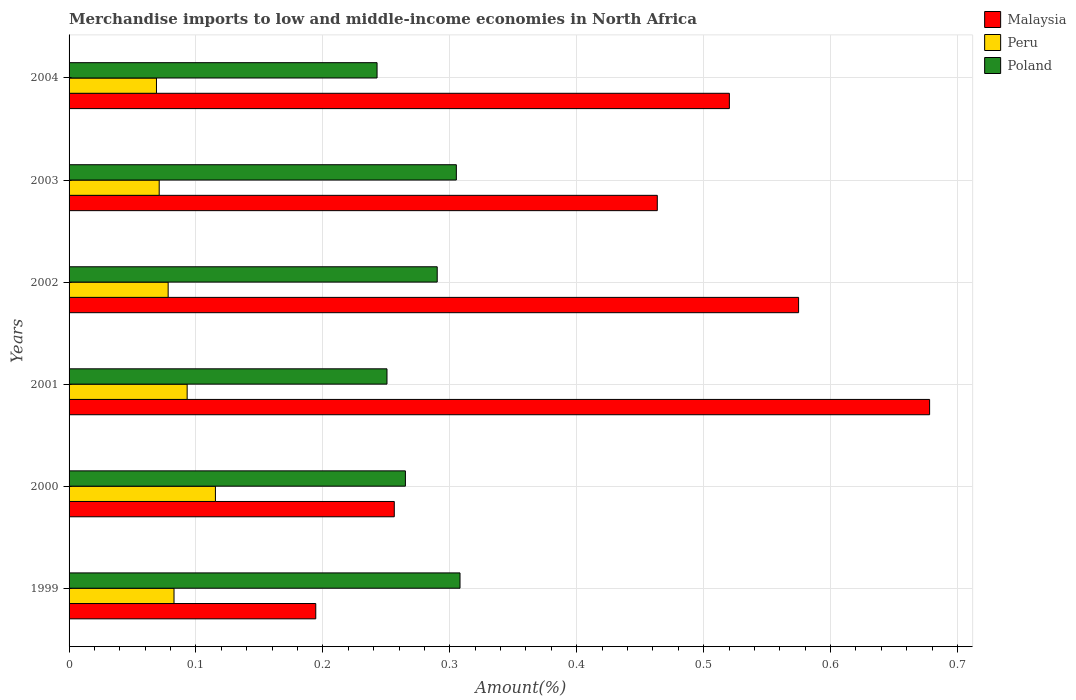How many different coloured bars are there?
Give a very brief answer. 3. In how many cases, is the number of bars for a given year not equal to the number of legend labels?
Keep it short and to the point. 0. What is the percentage of amount earned from merchandise imports in Peru in 2003?
Your response must be concise. 0.07. Across all years, what is the maximum percentage of amount earned from merchandise imports in Peru?
Offer a very short reply. 0.12. Across all years, what is the minimum percentage of amount earned from merchandise imports in Malaysia?
Your answer should be very brief. 0.19. In which year was the percentage of amount earned from merchandise imports in Peru maximum?
Your answer should be very brief. 2000. What is the total percentage of amount earned from merchandise imports in Peru in the graph?
Provide a succinct answer. 0.51. What is the difference between the percentage of amount earned from merchandise imports in Poland in 1999 and that in 2003?
Provide a succinct answer. 0. What is the difference between the percentage of amount earned from merchandise imports in Peru in 2004 and the percentage of amount earned from merchandise imports in Malaysia in 2001?
Give a very brief answer. -0.61. What is the average percentage of amount earned from merchandise imports in Malaysia per year?
Ensure brevity in your answer.  0.45. In the year 2004, what is the difference between the percentage of amount earned from merchandise imports in Poland and percentage of amount earned from merchandise imports in Peru?
Offer a very short reply. 0.17. In how many years, is the percentage of amount earned from merchandise imports in Peru greater than 0.28 %?
Give a very brief answer. 0. What is the ratio of the percentage of amount earned from merchandise imports in Poland in 2002 to that in 2004?
Provide a succinct answer. 1.2. Is the percentage of amount earned from merchandise imports in Peru in 1999 less than that in 2001?
Your answer should be very brief. Yes. Is the difference between the percentage of amount earned from merchandise imports in Poland in 1999 and 2004 greater than the difference between the percentage of amount earned from merchandise imports in Peru in 1999 and 2004?
Offer a very short reply. Yes. What is the difference between the highest and the second highest percentage of amount earned from merchandise imports in Peru?
Your answer should be very brief. 0.02. What is the difference between the highest and the lowest percentage of amount earned from merchandise imports in Poland?
Your answer should be compact. 0.07. Is the sum of the percentage of amount earned from merchandise imports in Peru in 1999 and 2001 greater than the maximum percentage of amount earned from merchandise imports in Poland across all years?
Offer a very short reply. No. What does the 1st bar from the bottom in 1999 represents?
Provide a succinct answer. Malaysia. How many bars are there?
Make the answer very short. 18. How many years are there in the graph?
Your answer should be very brief. 6. Are the values on the major ticks of X-axis written in scientific E-notation?
Provide a succinct answer. No. Does the graph contain any zero values?
Provide a succinct answer. No. How are the legend labels stacked?
Give a very brief answer. Vertical. What is the title of the graph?
Offer a very short reply. Merchandise imports to low and middle-income economies in North Africa. Does "Chad" appear as one of the legend labels in the graph?
Offer a very short reply. No. What is the label or title of the X-axis?
Offer a very short reply. Amount(%). What is the Amount(%) of Malaysia in 1999?
Give a very brief answer. 0.19. What is the Amount(%) in Peru in 1999?
Make the answer very short. 0.08. What is the Amount(%) of Poland in 1999?
Provide a short and direct response. 0.31. What is the Amount(%) of Malaysia in 2000?
Provide a succinct answer. 0.26. What is the Amount(%) of Peru in 2000?
Make the answer very short. 0.12. What is the Amount(%) of Poland in 2000?
Ensure brevity in your answer.  0.27. What is the Amount(%) of Malaysia in 2001?
Your answer should be compact. 0.68. What is the Amount(%) in Peru in 2001?
Offer a terse response. 0.09. What is the Amount(%) of Poland in 2001?
Provide a short and direct response. 0.25. What is the Amount(%) in Malaysia in 2002?
Make the answer very short. 0.57. What is the Amount(%) of Peru in 2002?
Your response must be concise. 0.08. What is the Amount(%) in Poland in 2002?
Your answer should be compact. 0.29. What is the Amount(%) of Malaysia in 2003?
Make the answer very short. 0.46. What is the Amount(%) in Peru in 2003?
Offer a terse response. 0.07. What is the Amount(%) in Poland in 2003?
Offer a very short reply. 0.31. What is the Amount(%) in Malaysia in 2004?
Give a very brief answer. 0.52. What is the Amount(%) in Peru in 2004?
Your answer should be compact. 0.07. What is the Amount(%) of Poland in 2004?
Give a very brief answer. 0.24. Across all years, what is the maximum Amount(%) of Malaysia?
Keep it short and to the point. 0.68. Across all years, what is the maximum Amount(%) of Peru?
Your answer should be compact. 0.12. Across all years, what is the maximum Amount(%) of Poland?
Your answer should be compact. 0.31. Across all years, what is the minimum Amount(%) in Malaysia?
Provide a succinct answer. 0.19. Across all years, what is the minimum Amount(%) in Peru?
Make the answer very short. 0.07. Across all years, what is the minimum Amount(%) of Poland?
Provide a succinct answer. 0.24. What is the total Amount(%) of Malaysia in the graph?
Give a very brief answer. 2.69. What is the total Amount(%) of Peru in the graph?
Provide a succinct answer. 0.51. What is the total Amount(%) in Poland in the graph?
Your answer should be very brief. 1.66. What is the difference between the Amount(%) in Malaysia in 1999 and that in 2000?
Keep it short and to the point. -0.06. What is the difference between the Amount(%) in Peru in 1999 and that in 2000?
Offer a terse response. -0.03. What is the difference between the Amount(%) in Poland in 1999 and that in 2000?
Keep it short and to the point. 0.04. What is the difference between the Amount(%) of Malaysia in 1999 and that in 2001?
Make the answer very short. -0.48. What is the difference between the Amount(%) in Peru in 1999 and that in 2001?
Provide a succinct answer. -0.01. What is the difference between the Amount(%) in Poland in 1999 and that in 2001?
Offer a terse response. 0.06. What is the difference between the Amount(%) of Malaysia in 1999 and that in 2002?
Ensure brevity in your answer.  -0.38. What is the difference between the Amount(%) in Peru in 1999 and that in 2002?
Your response must be concise. 0. What is the difference between the Amount(%) in Poland in 1999 and that in 2002?
Make the answer very short. 0.02. What is the difference between the Amount(%) of Malaysia in 1999 and that in 2003?
Give a very brief answer. -0.27. What is the difference between the Amount(%) of Peru in 1999 and that in 2003?
Ensure brevity in your answer.  0.01. What is the difference between the Amount(%) in Poland in 1999 and that in 2003?
Keep it short and to the point. 0. What is the difference between the Amount(%) of Malaysia in 1999 and that in 2004?
Give a very brief answer. -0.33. What is the difference between the Amount(%) in Peru in 1999 and that in 2004?
Offer a terse response. 0.01. What is the difference between the Amount(%) of Poland in 1999 and that in 2004?
Give a very brief answer. 0.07. What is the difference between the Amount(%) in Malaysia in 2000 and that in 2001?
Offer a terse response. -0.42. What is the difference between the Amount(%) in Peru in 2000 and that in 2001?
Provide a succinct answer. 0.02. What is the difference between the Amount(%) in Poland in 2000 and that in 2001?
Keep it short and to the point. 0.01. What is the difference between the Amount(%) of Malaysia in 2000 and that in 2002?
Keep it short and to the point. -0.32. What is the difference between the Amount(%) in Peru in 2000 and that in 2002?
Your response must be concise. 0.04. What is the difference between the Amount(%) in Poland in 2000 and that in 2002?
Offer a terse response. -0.03. What is the difference between the Amount(%) of Malaysia in 2000 and that in 2003?
Your answer should be very brief. -0.21. What is the difference between the Amount(%) of Peru in 2000 and that in 2003?
Offer a terse response. 0.04. What is the difference between the Amount(%) of Poland in 2000 and that in 2003?
Your answer should be compact. -0.04. What is the difference between the Amount(%) in Malaysia in 2000 and that in 2004?
Give a very brief answer. -0.26. What is the difference between the Amount(%) of Peru in 2000 and that in 2004?
Your answer should be very brief. 0.05. What is the difference between the Amount(%) in Poland in 2000 and that in 2004?
Provide a short and direct response. 0.02. What is the difference between the Amount(%) in Malaysia in 2001 and that in 2002?
Your answer should be very brief. 0.1. What is the difference between the Amount(%) of Peru in 2001 and that in 2002?
Provide a short and direct response. 0.01. What is the difference between the Amount(%) of Poland in 2001 and that in 2002?
Make the answer very short. -0.04. What is the difference between the Amount(%) of Malaysia in 2001 and that in 2003?
Keep it short and to the point. 0.21. What is the difference between the Amount(%) in Peru in 2001 and that in 2003?
Your answer should be compact. 0.02. What is the difference between the Amount(%) in Poland in 2001 and that in 2003?
Your response must be concise. -0.05. What is the difference between the Amount(%) of Malaysia in 2001 and that in 2004?
Offer a terse response. 0.16. What is the difference between the Amount(%) of Peru in 2001 and that in 2004?
Make the answer very short. 0.02. What is the difference between the Amount(%) of Poland in 2001 and that in 2004?
Make the answer very short. 0.01. What is the difference between the Amount(%) in Malaysia in 2002 and that in 2003?
Provide a short and direct response. 0.11. What is the difference between the Amount(%) of Peru in 2002 and that in 2003?
Your response must be concise. 0.01. What is the difference between the Amount(%) in Poland in 2002 and that in 2003?
Your answer should be very brief. -0.02. What is the difference between the Amount(%) of Malaysia in 2002 and that in 2004?
Your response must be concise. 0.05. What is the difference between the Amount(%) of Peru in 2002 and that in 2004?
Ensure brevity in your answer.  0.01. What is the difference between the Amount(%) of Poland in 2002 and that in 2004?
Your answer should be very brief. 0.05. What is the difference between the Amount(%) in Malaysia in 2003 and that in 2004?
Provide a succinct answer. -0.06. What is the difference between the Amount(%) of Peru in 2003 and that in 2004?
Your answer should be compact. 0. What is the difference between the Amount(%) in Poland in 2003 and that in 2004?
Provide a succinct answer. 0.06. What is the difference between the Amount(%) of Malaysia in 1999 and the Amount(%) of Peru in 2000?
Make the answer very short. 0.08. What is the difference between the Amount(%) of Malaysia in 1999 and the Amount(%) of Poland in 2000?
Make the answer very short. -0.07. What is the difference between the Amount(%) in Peru in 1999 and the Amount(%) in Poland in 2000?
Offer a very short reply. -0.18. What is the difference between the Amount(%) of Malaysia in 1999 and the Amount(%) of Peru in 2001?
Keep it short and to the point. 0.1. What is the difference between the Amount(%) in Malaysia in 1999 and the Amount(%) in Poland in 2001?
Give a very brief answer. -0.06. What is the difference between the Amount(%) in Peru in 1999 and the Amount(%) in Poland in 2001?
Provide a succinct answer. -0.17. What is the difference between the Amount(%) of Malaysia in 1999 and the Amount(%) of Peru in 2002?
Keep it short and to the point. 0.12. What is the difference between the Amount(%) in Malaysia in 1999 and the Amount(%) in Poland in 2002?
Provide a short and direct response. -0.1. What is the difference between the Amount(%) of Peru in 1999 and the Amount(%) of Poland in 2002?
Offer a terse response. -0.21. What is the difference between the Amount(%) in Malaysia in 1999 and the Amount(%) in Peru in 2003?
Offer a very short reply. 0.12. What is the difference between the Amount(%) in Malaysia in 1999 and the Amount(%) in Poland in 2003?
Your answer should be very brief. -0.11. What is the difference between the Amount(%) of Peru in 1999 and the Amount(%) of Poland in 2003?
Your answer should be compact. -0.22. What is the difference between the Amount(%) in Malaysia in 1999 and the Amount(%) in Peru in 2004?
Offer a very short reply. 0.13. What is the difference between the Amount(%) of Malaysia in 1999 and the Amount(%) of Poland in 2004?
Your answer should be compact. -0.05. What is the difference between the Amount(%) of Peru in 1999 and the Amount(%) of Poland in 2004?
Give a very brief answer. -0.16. What is the difference between the Amount(%) in Malaysia in 2000 and the Amount(%) in Peru in 2001?
Offer a very short reply. 0.16. What is the difference between the Amount(%) of Malaysia in 2000 and the Amount(%) of Poland in 2001?
Make the answer very short. 0.01. What is the difference between the Amount(%) in Peru in 2000 and the Amount(%) in Poland in 2001?
Offer a terse response. -0.14. What is the difference between the Amount(%) of Malaysia in 2000 and the Amount(%) of Peru in 2002?
Ensure brevity in your answer.  0.18. What is the difference between the Amount(%) in Malaysia in 2000 and the Amount(%) in Poland in 2002?
Make the answer very short. -0.03. What is the difference between the Amount(%) of Peru in 2000 and the Amount(%) of Poland in 2002?
Offer a very short reply. -0.17. What is the difference between the Amount(%) of Malaysia in 2000 and the Amount(%) of Peru in 2003?
Offer a terse response. 0.19. What is the difference between the Amount(%) of Malaysia in 2000 and the Amount(%) of Poland in 2003?
Ensure brevity in your answer.  -0.05. What is the difference between the Amount(%) of Peru in 2000 and the Amount(%) of Poland in 2003?
Your answer should be compact. -0.19. What is the difference between the Amount(%) in Malaysia in 2000 and the Amount(%) in Peru in 2004?
Offer a very short reply. 0.19. What is the difference between the Amount(%) of Malaysia in 2000 and the Amount(%) of Poland in 2004?
Your response must be concise. 0.01. What is the difference between the Amount(%) in Peru in 2000 and the Amount(%) in Poland in 2004?
Make the answer very short. -0.13. What is the difference between the Amount(%) in Malaysia in 2001 and the Amount(%) in Peru in 2002?
Your answer should be very brief. 0.6. What is the difference between the Amount(%) of Malaysia in 2001 and the Amount(%) of Poland in 2002?
Make the answer very short. 0.39. What is the difference between the Amount(%) in Peru in 2001 and the Amount(%) in Poland in 2002?
Make the answer very short. -0.2. What is the difference between the Amount(%) of Malaysia in 2001 and the Amount(%) of Peru in 2003?
Your answer should be very brief. 0.61. What is the difference between the Amount(%) of Malaysia in 2001 and the Amount(%) of Poland in 2003?
Ensure brevity in your answer.  0.37. What is the difference between the Amount(%) in Peru in 2001 and the Amount(%) in Poland in 2003?
Your answer should be very brief. -0.21. What is the difference between the Amount(%) of Malaysia in 2001 and the Amount(%) of Peru in 2004?
Provide a succinct answer. 0.61. What is the difference between the Amount(%) in Malaysia in 2001 and the Amount(%) in Poland in 2004?
Ensure brevity in your answer.  0.44. What is the difference between the Amount(%) of Peru in 2001 and the Amount(%) of Poland in 2004?
Offer a terse response. -0.15. What is the difference between the Amount(%) of Malaysia in 2002 and the Amount(%) of Peru in 2003?
Your answer should be compact. 0.5. What is the difference between the Amount(%) in Malaysia in 2002 and the Amount(%) in Poland in 2003?
Keep it short and to the point. 0.27. What is the difference between the Amount(%) of Peru in 2002 and the Amount(%) of Poland in 2003?
Offer a very short reply. -0.23. What is the difference between the Amount(%) in Malaysia in 2002 and the Amount(%) in Peru in 2004?
Make the answer very short. 0.51. What is the difference between the Amount(%) in Malaysia in 2002 and the Amount(%) in Poland in 2004?
Keep it short and to the point. 0.33. What is the difference between the Amount(%) of Peru in 2002 and the Amount(%) of Poland in 2004?
Your answer should be compact. -0.16. What is the difference between the Amount(%) in Malaysia in 2003 and the Amount(%) in Peru in 2004?
Offer a very short reply. 0.39. What is the difference between the Amount(%) in Malaysia in 2003 and the Amount(%) in Poland in 2004?
Ensure brevity in your answer.  0.22. What is the difference between the Amount(%) in Peru in 2003 and the Amount(%) in Poland in 2004?
Your response must be concise. -0.17. What is the average Amount(%) of Malaysia per year?
Keep it short and to the point. 0.45. What is the average Amount(%) in Peru per year?
Make the answer very short. 0.08. What is the average Amount(%) of Poland per year?
Make the answer very short. 0.28. In the year 1999, what is the difference between the Amount(%) of Malaysia and Amount(%) of Peru?
Your answer should be very brief. 0.11. In the year 1999, what is the difference between the Amount(%) of Malaysia and Amount(%) of Poland?
Your answer should be very brief. -0.11. In the year 1999, what is the difference between the Amount(%) of Peru and Amount(%) of Poland?
Provide a succinct answer. -0.23. In the year 2000, what is the difference between the Amount(%) of Malaysia and Amount(%) of Peru?
Ensure brevity in your answer.  0.14. In the year 2000, what is the difference between the Amount(%) in Malaysia and Amount(%) in Poland?
Give a very brief answer. -0.01. In the year 2000, what is the difference between the Amount(%) in Peru and Amount(%) in Poland?
Provide a short and direct response. -0.15. In the year 2001, what is the difference between the Amount(%) of Malaysia and Amount(%) of Peru?
Provide a short and direct response. 0.58. In the year 2001, what is the difference between the Amount(%) in Malaysia and Amount(%) in Poland?
Your answer should be compact. 0.43. In the year 2001, what is the difference between the Amount(%) in Peru and Amount(%) in Poland?
Provide a succinct answer. -0.16. In the year 2002, what is the difference between the Amount(%) in Malaysia and Amount(%) in Peru?
Offer a very short reply. 0.5. In the year 2002, what is the difference between the Amount(%) in Malaysia and Amount(%) in Poland?
Make the answer very short. 0.28. In the year 2002, what is the difference between the Amount(%) of Peru and Amount(%) of Poland?
Your response must be concise. -0.21. In the year 2003, what is the difference between the Amount(%) in Malaysia and Amount(%) in Peru?
Offer a terse response. 0.39. In the year 2003, what is the difference between the Amount(%) of Malaysia and Amount(%) of Poland?
Your answer should be very brief. 0.16. In the year 2003, what is the difference between the Amount(%) of Peru and Amount(%) of Poland?
Provide a succinct answer. -0.23. In the year 2004, what is the difference between the Amount(%) in Malaysia and Amount(%) in Peru?
Your response must be concise. 0.45. In the year 2004, what is the difference between the Amount(%) of Malaysia and Amount(%) of Poland?
Ensure brevity in your answer.  0.28. In the year 2004, what is the difference between the Amount(%) in Peru and Amount(%) in Poland?
Ensure brevity in your answer.  -0.17. What is the ratio of the Amount(%) in Malaysia in 1999 to that in 2000?
Give a very brief answer. 0.76. What is the ratio of the Amount(%) in Peru in 1999 to that in 2000?
Provide a short and direct response. 0.72. What is the ratio of the Amount(%) in Poland in 1999 to that in 2000?
Offer a terse response. 1.16. What is the ratio of the Amount(%) in Malaysia in 1999 to that in 2001?
Your response must be concise. 0.29. What is the ratio of the Amount(%) in Peru in 1999 to that in 2001?
Your response must be concise. 0.89. What is the ratio of the Amount(%) in Poland in 1999 to that in 2001?
Your response must be concise. 1.23. What is the ratio of the Amount(%) in Malaysia in 1999 to that in 2002?
Ensure brevity in your answer.  0.34. What is the ratio of the Amount(%) of Peru in 1999 to that in 2002?
Give a very brief answer. 1.06. What is the ratio of the Amount(%) in Poland in 1999 to that in 2002?
Your answer should be compact. 1.06. What is the ratio of the Amount(%) in Malaysia in 1999 to that in 2003?
Provide a short and direct response. 0.42. What is the ratio of the Amount(%) in Peru in 1999 to that in 2003?
Ensure brevity in your answer.  1.16. What is the ratio of the Amount(%) in Poland in 1999 to that in 2003?
Provide a succinct answer. 1.01. What is the ratio of the Amount(%) in Malaysia in 1999 to that in 2004?
Your answer should be compact. 0.37. What is the ratio of the Amount(%) of Peru in 1999 to that in 2004?
Provide a succinct answer. 1.2. What is the ratio of the Amount(%) in Poland in 1999 to that in 2004?
Provide a succinct answer. 1.27. What is the ratio of the Amount(%) of Malaysia in 2000 to that in 2001?
Your answer should be compact. 0.38. What is the ratio of the Amount(%) of Peru in 2000 to that in 2001?
Your answer should be very brief. 1.24. What is the ratio of the Amount(%) of Poland in 2000 to that in 2001?
Offer a terse response. 1.06. What is the ratio of the Amount(%) in Malaysia in 2000 to that in 2002?
Give a very brief answer. 0.45. What is the ratio of the Amount(%) in Peru in 2000 to that in 2002?
Your answer should be very brief. 1.48. What is the ratio of the Amount(%) of Poland in 2000 to that in 2002?
Offer a terse response. 0.91. What is the ratio of the Amount(%) in Malaysia in 2000 to that in 2003?
Keep it short and to the point. 0.55. What is the ratio of the Amount(%) of Peru in 2000 to that in 2003?
Offer a very short reply. 1.62. What is the ratio of the Amount(%) in Poland in 2000 to that in 2003?
Provide a short and direct response. 0.87. What is the ratio of the Amount(%) of Malaysia in 2000 to that in 2004?
Your answer should be compact. 0.49. What is the ratio of the Amount(%) of Peru in 2000 to that in 2004?
Keep it short and to the point. 1.67. What is the ratio of the Amount(%) in Poland in 2000 to that in 2004?
Make the answer very short. 1.09. What is the ratio of the Amount(%) of Malaysia in 2001 to that in 2002?
Give a very brief answer. 1.18. What is the ratio of the Amount(%) in Peru in 2001 to that in 2002?
Provide a short and direct response. 1.19. What is the ratio of the Amount(%) in Poland in 2001 to that in 2002?
Give a very brief answer. 0.86. What is the ratio of the Amount(%) in Malaysia in 2001 to that in 2003?
Ensure brevity in your answer.  1.46. What is the ratio of the Amount(%) in Peru in 2001 to that in 2003?
Offer a terse response. 1.31. What is the ratio of the Amount(%) of Poland in 2001 to that in 2003?
Offer a terse response. 0.82. What is the ratio of the Amount(%) of Malaysia in 2001 to that in 2004?
Your answer should be compact. 1.3. What is the ratio of the Amount(%) of Peru in 2001 to that in 2004?
Your response must be concise. 1.35. What is the ratio of the Amount(%) of Poland in 2001 to that in 2004?
Your answer should be very brief. 1.03. What is the ratio of the Amount(%) in Malaysia in 2002 to that in 2003?
Make the answer very short. 1.24. What is the ratio of the Amount(%) of Peru in 2002 to that in 2003?
Offer a very short reply. 1.1. What is the ratio of the Amount(%) in Poland in 2002 to that in 2003?
Make the answer very short. 0.95. What is the ratio of the Amount(%) of Malaysia in 2002 to that in 2004?
Make the answer very short. 1.1. What is the ratio of the Amount(%) in Peru in 2002 to that in 2004?
Your answer should be compact. 1.13. What is the ratio of the Amount(%) in Poland in 2002 to that in 2004?
Keep it short and to the point. 1.2. What is the ratio of the Amount(%) of Malaysia in 2003 to that in 2004?
Your response must be concise. 0.89. What is the ratio of the Amount(%) of Peru in 2003 to that in 2004?
Your response must be concise. 1.03. What is the ratio of the Amount(%) in Poland in 2003 to that in 2004?
Provide a succinct answer. 1.26. What is the difference between the highest and the second highest Amount(%) of Malaysia?
Your answer should be compact. 0.1. What is the difference between the highest and the second highest Amount(%) in Peru?
Provide a succinct answer. 0.02. What is the difference between the highest and the second highest Amount(%) of Poland?
Make the answer very short. 0. What is the difference between the highest and the lowest Amount(%) in Malaysia?
Provide a short and direct response. 0.48. What is the difference between the highest and the lowest Amount(%) in Peru?
Provide a succinct answer. 0.05. What is the difference between the highest and the lowest Amount(%) of Poland?
Give a very brief answer. 0.07. 